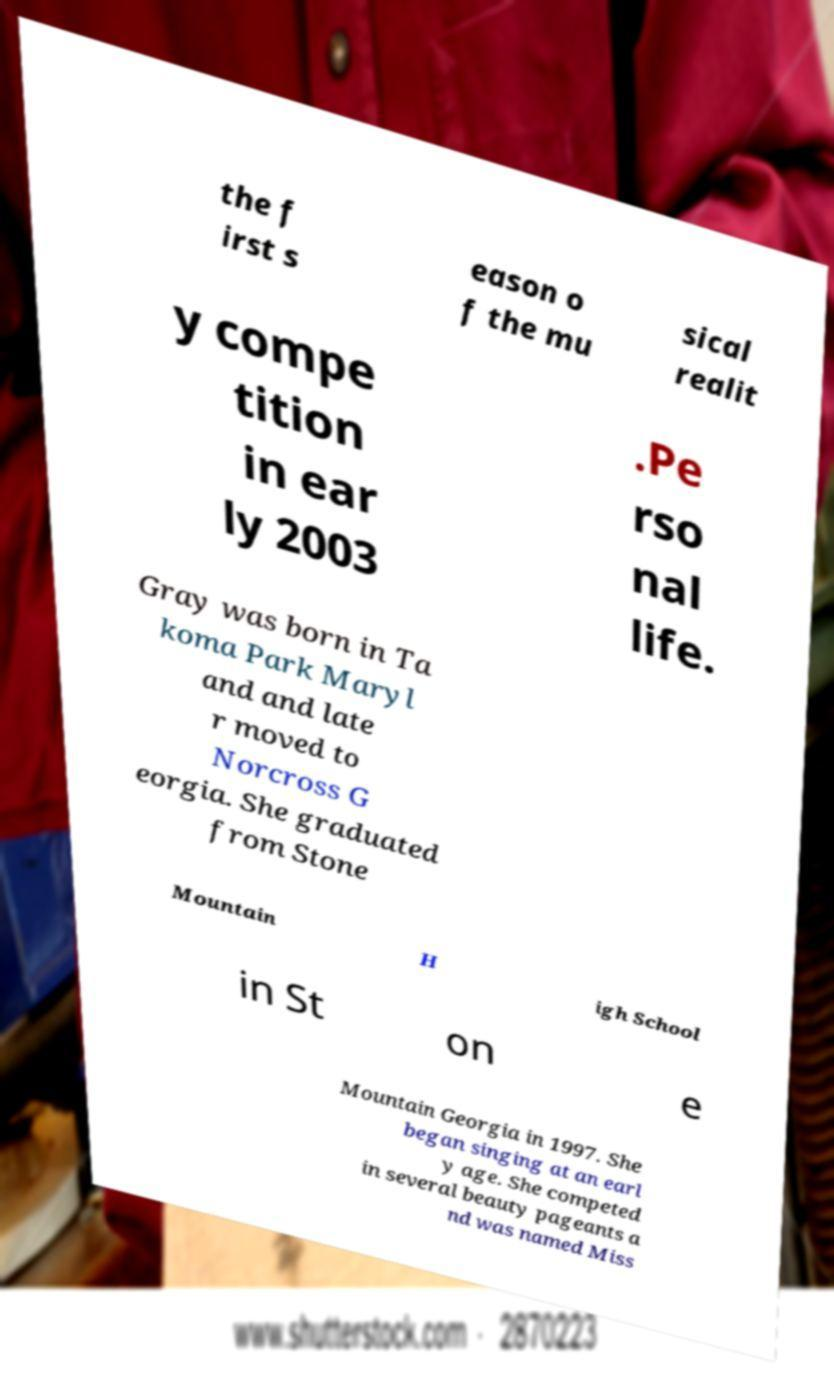Could you extract and type out the text from this image? the f irst s eason o f the mu sical realit y compe tition in ear ly 2003 .Pe rso nal life. Gray was born in Ta koma Park Maryl and and late r moved to Norcross G eorgia. She graduated from Stone Mountain H igh School in St on e Mountain Georgia in 1997. She began singing at an earl y age. She competed in several beauty pageants a nd was named Miss 